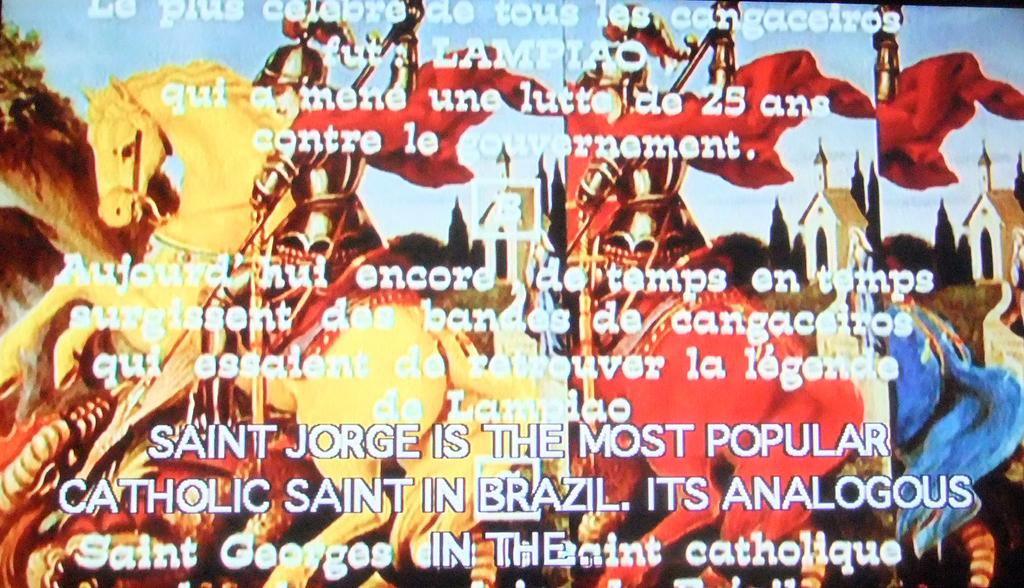<image>
Provide a brief description of the given image. GLADIATORS IN GOLD AND RED RIDING ON HORSES WITH "SAINT JORGE IS THE MOST POPULAR CATHOLIC SAINT IN BRAZIL. WRITTEN ABOVE THE IMAGE. 